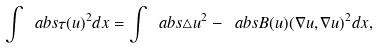Convert formula to latex. <formula><loc_0><loc_0><loc_500><loc_500>\int \ a b s { \tau ( u ) } ^ { 2 } d x = \int \ a b s { \triangle u } ^ { 2 } - \ a b s { B ( u ) ( \nabla u , \nabla u ) } ^ { 2 } d x ,</formula> 